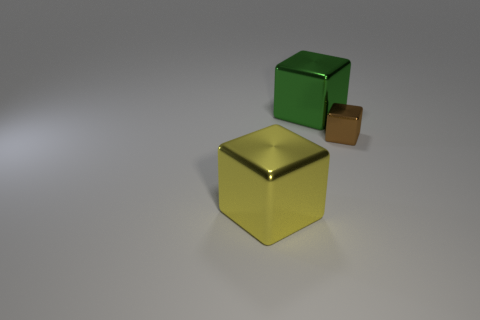Is there any other thing that has the same size as the brown metallic block?
Give a very brief answer. No. There is a big green thing that is made of the same material as the small thing; what shape is it?
Make the answer very short. Cube. What size is the cube that is to the right of the green shiny object?
Your answer should be compact. Small. There is a large green thing; what shape is it?
Offer a very short reply. Cube. There is a shiny thing that is left of the green metallic cube; is its size the same as the green metallic thing on the left side of the small brown shiny cube?
Ensure brevity in your answer.  Yes. What is the size of the yellow metal thing in front of the large metallic object behind the large block that is in front of the brown shiny block?
Provide a succinct answer. Large. What shape is the large shiny object that is to the right of the object that is in front of the metal thing that is on the right side of the green metal object?
Your response must be concise. Cube. What is the shape of the thing that is in front of the small metallic cube?
Provide a short and direct response. Cube. Is the color of the tiny shiny object the same as the large cube in front of the green metallic object?
Ensure brevity in your answer.  No. What shape is the large shiny thing that is on the right side of the large yellow metallic object in front of the large green thing?
Your answer should be compact. Cube. 